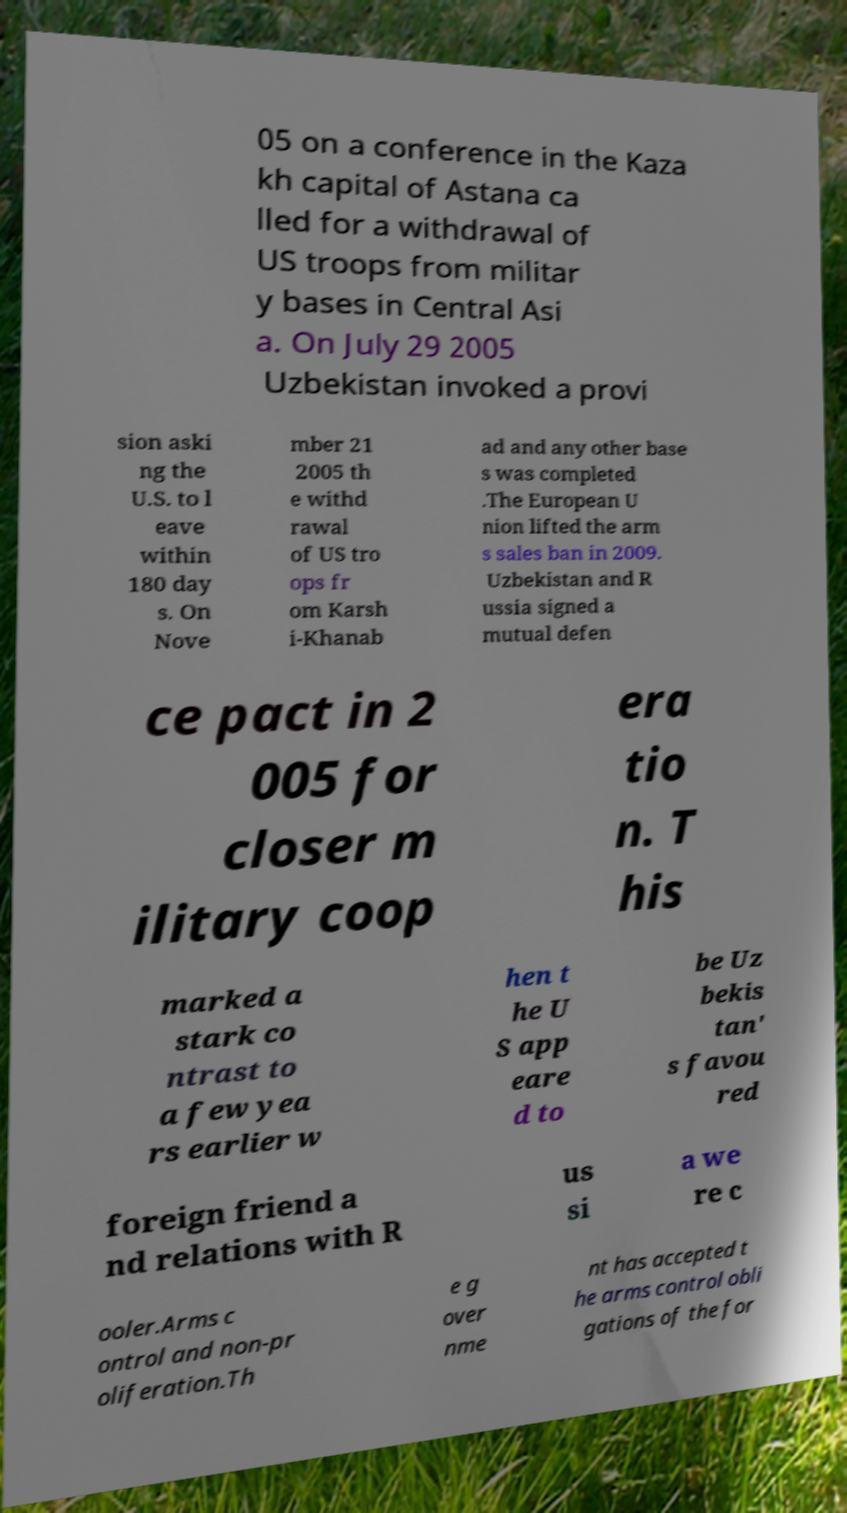I need the written content from this picture converted into text. Can you do that? 05 on a conference in the Kaza kh capital of Astana ca lled for a withdrawal of US troops from militar y bases in Central Asi a. On July 29 2005 Uzbekistan invoked a provi sion aski ng the U.S. to l eave within 180 day s. On Nove mber 21 2005 th e withd rawal of US tro ops fr om Karsh i-Khanab ad and any other base s was completed .The European U nion lifted the arm s sales ban in 2009. Uzbekistan and R ussia signed a mutual defen ce pact in 2 005 for closer m ilitary coop era tio n. T his marked a stark co ntrast to a few yea rs earlier w hen t he U S app eare d to be Uz bekis tan' s favou red foreign friend a nd relations with R us si a we re c ooler.Arms c ontrol and non-pr oliferation.Th e g over nme nt has accepted t he arms control obli gations of the for 